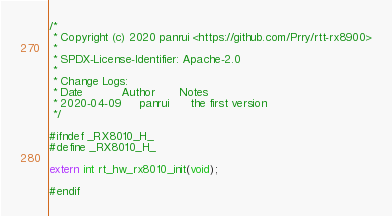<code> <loc_0><loc_0><loc_500><loc_500><_C_>
/*
 * Copyright (c) 2020 panrui <https://github.com/Prry/rtt-rx8900>
 *
 * SPDX-License-Identifier: Apache-2.0
 *
 * Change Logs:
 * Date           Author       Notes
 * 2020-04-09     panrui      the first version
 */

#ifndef _RX8010_H_
#define _RX8010_H_

extern int rt_hw_rx8010_init(void);

#endif
</code> 